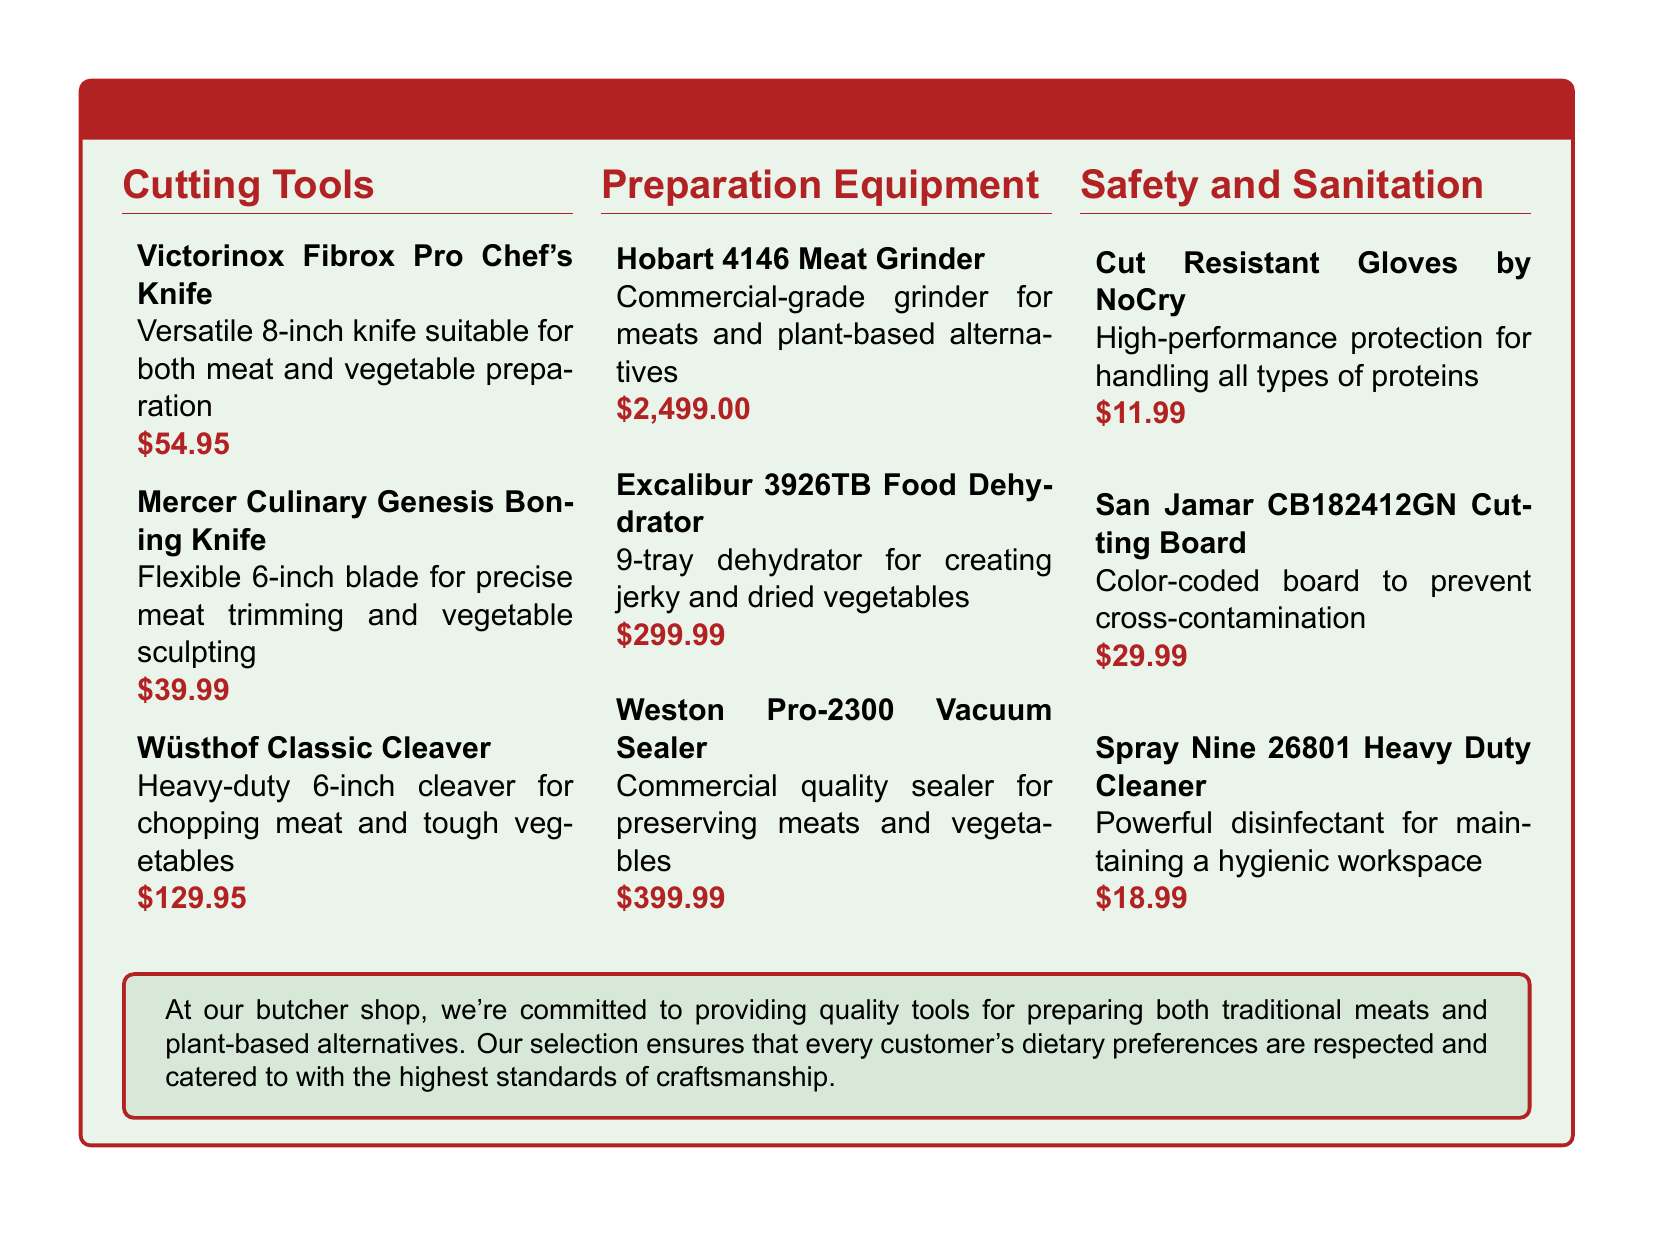What is the price of the Victorinox Fibrox Pro Chef's Knife? The price is listed under the cutting tools section.
Answer: $54.95 What is the primary function of the Hobart 4146 Meat Grinder? The primary function is indicated in the preparation equipment section of the document.
Answer: Commercial-grade grinder for meats and plant-based alternatives How many trays does the Excalibur 3926TB Food Dehydrator have? The number of trays is specified in the description of the food dehydrator.
Answer: 9-tray What is the function of the San Jamar CB182412GN Cutting Board? The function is related to food safety and is described in the safety and sanitation section.
Answer: Prevent cross-contamination Which tool is suitable for chopping tough vegetables? The suitability for chopping tough vegetables is mentioned in the description of a specific cutting tool.
Answer: Wüsthof Classic Cleaver What is the total cost of all safety and sanitation tools listed? The total cost can be calculated by adding the individual prices from the document.
Answer: $60.97 Which item is high-performance protection for handling all types of proteins? The specific tool is identified in the safety and sanitation section of the document.
Answer: Cut Resistant Gloves by NoCry What color-coded cutting board is used to prevent cross-contamination? The specific product is referenced in the safety and sanitation section.
Answer: San Jamar CB182412GN Cutting Board 